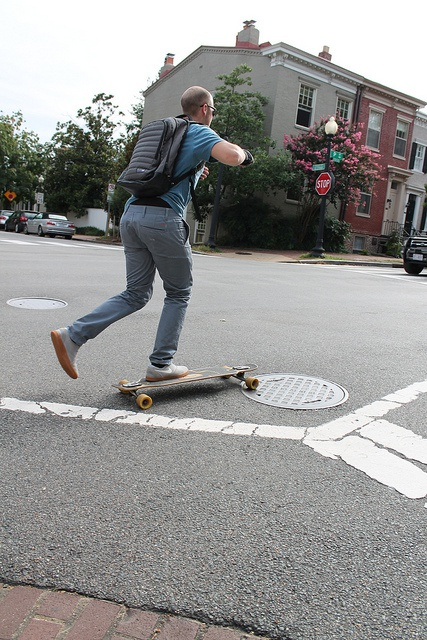Describe the objects in this image and their specific colors. I can see people in white, gray, black, and blue tones, backpack in white, black, gray, and darkgray tones, skateboard in white, darkgray, black, gray, and lightgray tones, car in white, gray, darkgray, black, and lightgray tones, and car in white, black, gray, darkgray, and purple tones in this image. 